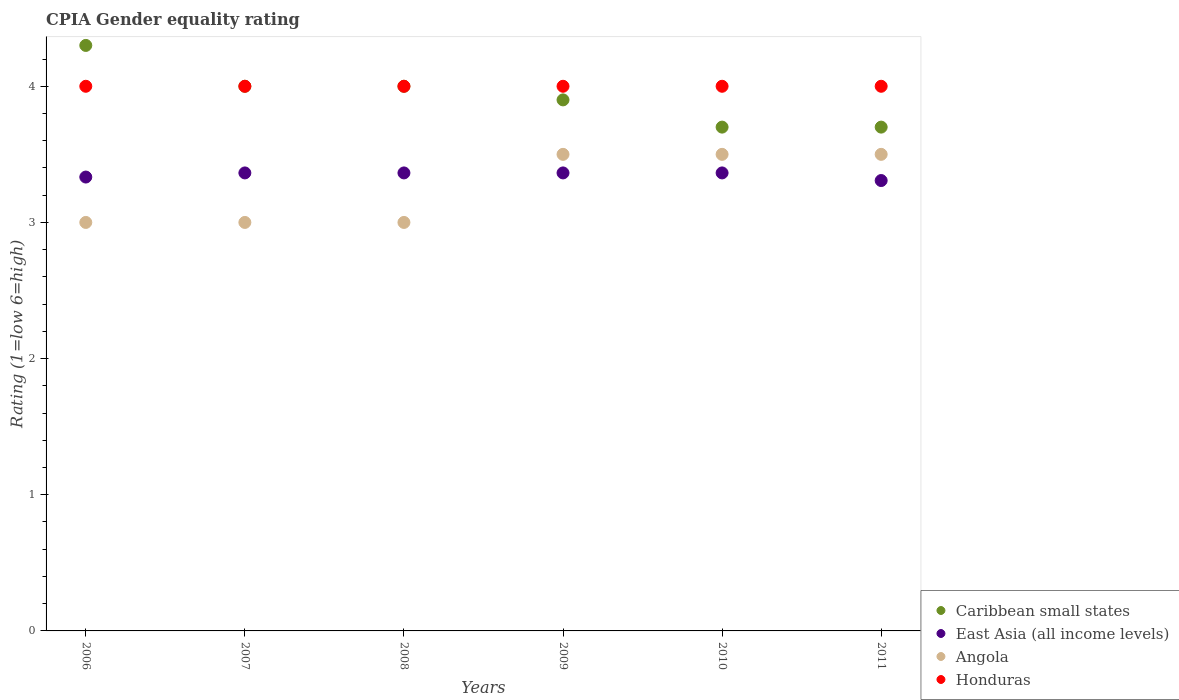How many different coloured dotlines are there?
Keep it short and to the point. 4. Is the number of dotlines equal to the number of legend labels?
Provide a short and direct response. Yes. What is the CPIA rating in East Asia (all income levels) in 2008?
Ensure brevity in your answer.  3.36. Across all years, what is the maximum CPIA rating in Angola?
Your answer should be compact. 3.5. What is the difference between the CPIA rating in Angola in 2006 and that in 2011?
Offer a very short reply. -0.5. What is the difference between the CPIA rating in Honduras in 2006 and the CPIA rating in East Asia (all income levels) in 2011?
Provide a short and direct response. 0.69. What is the average CPIA rating in Caribbean small states per year?
Provide a short and direct response. 3.93. In the year 2010, what is the difference between the CPIA rating in East Asia (all income levels) and CPIA rating in Caribbean small states?
Provide a short and direct response. -0.34. In how many years, is the CPIA rating in Honduras greater than 1.8?
Keep it short and to the point. 6. What is the ratio of the CPIA rating in East Asia (all income levels) in 2006 to that in 2010?
Ensure brevity in your answer.  0.99. Is the CPIA rating in Honduras in 2009 less than that in 2010?
Offer a terse response. No. What is the difference between the highest and the second highest CPIA rating in Caribbean small states?
Ensure brevity in your answer.  0.3. In how many years, is the CPIA rating in Caribbean small states greater than the average CPIA rating in Caribbean small states taken over all years?
Your answer should be compact. 3. Is it the case that in every year, the sum of the CPIA rating in Caribbean small states and CPIA rating in Honduras  is greater than the sum of CPIA rating in East Asia (all income levels) and CPIA rating in Angola?
Provide a short and direct response. No. Is it the case that in every year, the sum of the CPIA rating in Angola and CPIA rating in Honduras  is greater than the CPIA rating in Caribbean small states?
Provide a short and direct response. Yes. Is the CPIA rating in Honduras strictly less than the CPIA rating in East Asia (all income levels) over the years?
Your answer should be very brief. No. What is the difference between two consecutive major ticks on the Y-axis?
Ensure brevity in your answer.  1. Does the graph contain any zero values?
Your answer should be compact. No. Does the graph contain grids?
Provide a short and direct response. No. Where does the legend appear in the graph?
Provide a short and direct response. Bottom right. How many legend labels are there?
Make the answer very short. 4. How are the legend labels stacked?
Make the answer very short. Vertical. What is the title of the graph?
Give a very brief answer. CPIA Gender equality rating. Does "Congo (Republic)" appear as one of the legend labels in the graph?
Ensure brevity in your answer.  No. What is the label or title of the Y-axis?
Make the answer very short. Rating (1=low 6=high). What is the Rating (1=low 6=high) in East Asia (all income levels) in 2006?
Your answer should be very brief. 3.33. What is the Rating (1=low 6=high) in Caribbean small states in 2007?
Keep it short and to the point. 4. What is the Rating (1=low 6=high) in East Asia (all income levels) in 2007?
Provide a short and direct response. 3.36. What is the Rating (1=low 6=high) in Angola in 2007?
Keep it short and to the point. 3. What is the Rating (1=low 6=high) of Honduras in 2007?
Make the answer very short. 4. What is the Rating (1=low 6=high) in East Asia (all income levels) in 2008?
Your answer should be very brief. 3.36. What is the Rating (1=low 6=high) of Honduras in 2008?
Provide a short and direct response. 4. What is the Rating (1=low 6=high) in Caribbean small states in 2009?
Provide a succinct answer. 3.9. What is the Rating (1=low 6=high) of East Asia (all income levels) in 2009?
Ensure brevity in your answer.  3.36. What is the Rating (1=low 6=high) of Angola in 2009?
Give a very brief answer. 3.5. What is the Rating (1=low 6=high) of East Asia (all income levels) in 2010?
Make the answer very short. 3.36. What is the Rating (1=low 6=high) of Caribbean small states in 2011?
Provide a short and direct response. 3.7. What is the Rating (1=low 6=high) in East Asia (all income levels) in 2011?
Your answer should be very brief. 3.31. What is the Rating (1=low 6=high) in Angola in 2011?
Offer a very short reply. 3.5. What is the Rating (1=low 6=high) of Honduras in 2011?
Offer a terse response. 4. Across all years, what is the maximum Rating (1=low 6=high) in Caribbean small states?
Offer a terse response. 4.3. Across all years, what is the maximum Rating (1=low 6=high) of East Asia (all income levels)?
Your answer should be compact. 3.36. Across all years, what is the maximum Rating (1=low 6=high) of Honduras?
Give a very brief answer. 4. Across all years, what is the minimum Rating (1=low 6=high) of East Asia (all income levels)?
Make the answer very short. 3.31. Across all years, what is the minimum Rating (1=low 6=high) of Angola?
Make the answer very short. 3. What is the total Rating (1=low 6=high) in Caribbean small states in the graph?
Make the answer very short. 23.6. What is the total Rating (1=low 6=high) of East Asia (all income levels) in the graph?
Your answer should be very brief. 20.1. What is the total Rating (1=low 6=high) of Honduras in the graph?
Offer a terse response. 24. What is the difference between the Rating (1=low 6=high) in East Asia (all income levels) in 2006 and that in 2007?
Offer a very short reply. -0.03. What is the difference between the Rating (1=low 6=high) in Angola in 2006 and that in 2007?
Your response must be concise. 0. What is the difference between the Rating (1=low 6=high) in Honduras in 2006 and that in 2007?
Your answer should be compact. 0. What is the difference between the Rating (1=low 6=high) of East Asia (all income levels) in 2006 and that in 2008?
Keep it short and to the point. -0.03. What is the difference between the Rating (1=low 6=high) in Honduras in 2006 and that in 2008?
Offer a terse response. 0. What is the difference between the Rating (1=low 6=high) in East Asia (all income levels) in 2006 and that in 2009?
Keep it short and to the point. -0.03. What is the difference between the Rating (1=low 6=high) in Honduras in 2006 and that in 2009?
Your answer should be compact. 0. What is the difference between the Rating (1=low 6=high) of Caribbean small states in 2006 and that in 2010?
Your answer should be very brief. 0.6. What is the difference between the Rating (1=low 6=high) of East Asia (all income levels) in 2006 and that in 2010?
Provide a succinct answer. -0.03. What is the difference between the Rating (1=low 6=high) of Honduras in 2006 and that in 2010?
Your answer should be compact. 0. What is the difference between the Rating (1=low 6=high) of East Asia (all income levels) in 2006 and that in 2011?
Provide a short and direct response. 0.03. What is the difference between the Rating (1=low 6=high) in Caribbean small states in 2007 and that in 2008?
Offer a terse response. 0. What is the difference between the Rating (1=low 6=high) of Angola in 2007 and that in 2008?
Make the answer very short. 0. What is the difference between the Rating (1=low 6=high) in Honduras in 2007 and that in 2008?
Your response must be concise. 0. What is the difference between the Rating (1=low 6=high) of Caribbean small states in 2007 and that in 2009?
Provide a short and direct response. 0.1. What is the difference between the Rating (1=low 6=high) of Caribbean small states in 2007 and that in 2011?
Offer a terse response. 0.3. What is the difference between the Rating (1=low 6=high) of East Asia (all income levels) in 2007 and that in 2011?
Provide a short and direct response. 0.06. What is the difference between the Rating (1=low 6=high) of Angola in 2007 and that in 2011?
Your answer should be very brief. -0.5. What is the difference between the Rating (1=low 6=high) in Honduras in 2008 and that in 2009?
Offer a very short reply. 0. What is the difference between the Rating (1=low 6=high) of Caribbean small states in 2008 and that in 2010?
Ensure brevity in your answer.  0.3. What is the difference between the Rating (1=low 6=high) of Honduras in 2008 and that in 2010?
Make the answer very short. 0. What is the difference between the Rating (1=low 6=high) in East Asia (all income levels) in 2008 and that in 2011?
Ensure brevity in your answer.  0.06. What is the difference between the Rating (1=low 6=high) of East Asia (all income levels) in 2009 and that in 2010?
Your answer should be compact. 0. What is the difference between the Rating (1=low 6=high) of Honduras in 2009 and that in 2010?
Your response must be concise. 0. What is the difference between the Rating (1=low 6=high) of East Asia (all income levels) in 2009 and that in 2011?
Provide a short and direct response. 0.06. What is the difference between the Rating (1=low 6=high) of Caribbean small states in 2010 and that in 2011?
Ensure brevity in your answer.  0. What is the difference between the Rating (1=low 6=high) in East Asia (all income levels) in 2010 and that in 2011?
Provide a succinct answer. 0.06. What is the difference between the Rating (1=low 6=high) of Angola in 2010 and that in 2011?
Give a very brief answer. 0. What is the difference between the Rating (1=low 6=high) of Caribbean small states in 2006 and the Rating (1=low 6=high) of East Asia (all income levels) in 2007?
Provide a succinct answer. 0.94. What is the difference between the Rating (1=low 6=high) in Caribbean small states in 2006 and the Rating (1=low 6=high) in East Asia (all income levels) in 2008?
Make the answer very short. 0.94. What is the difference between the Rating (1=low 6=high) of Caribbean small states in 2006 and the Rating (1=low 6=high) of Honduras in 2008?
Your answer should be very brief. 0.3. What is the difference between the Rating (1=low 6=high) of East Asia (all income levels) in 2006 and the Rating (1=low 6=high) of Honduras in 2008?
Provide a succinct answer. -0.67. What is the difference between the Rating (1=low 6=high) in Caribbean small states in 2006 and the Rating (1=low 6=high) in East Asia (all income levels) in 2009?
Your response must be concise. 0.94. What is the difference between the Rating (1=low 6=high) in Caribbean small states in 2006 and the Rating (1=low 6=high) in Angola in 2009?
Keep it short and to the point. 0.8. What is the difference between the Rating (1=low 6=high) in Caribbean small states in 2006 and the Rating (1=low 6=high) in Honduras in 2009?
Ensure brevity in your answer.  0.3. What is the difference between the Rating (1=low 6=high) of East Asia (all income levels) in 2006 and the Rating (1=low 6=high) of Angola in 2009?
Provide a short and direct response. -0.17. What is the difference between the Rating (1=low 6=high) in Angola in 2006 and the Rating (1=low 6=high) in Honduras in 2009?
Provide a succinct answer. -1. What is the difference between the Rating (1=low 6=high) in Caribbean small states in 2006 and the Rating (1=low 6=high) in East Asia (all income levels) in 2010?
Offer a terse response. 0.94. What is the difference between the Rating (1=low 6=high) in Caribbean small states in 2006 and the Rating (1=low 6=high) in Angola in 2010?
Offer a terse response. 0.8. What is the difference between the Rating (1=low 6=high) in Caribbean small states in 2006 and the Rating (1=low 6=high) in Honduras in 2010?
Your response must be concise. 0.3. What is the difference between the Rating (1=low 6=high) of Angola in 2006 and the Rating (1=low 6=high) of Honduras in 2010?
Provide a short and direct response. -1. What is the difference between the Rating (1=low 6=high) of East Asia (all income levels) in 2006 and the Rating (1=low 6=high) of Angola in 2011?
Keep it short and to the point. -0.17. What is the difference between the Rating (1=low 6=high) of East Asia (all income levels) in 2006 and the Rating (1=low 6=high) of Honduras in 2011?
Your response must be concise. -0.67. What is the difference between the Rating (1=low 6=high) of Angola in 2006 and the Rating (1=low 6=high) of Honduras in 2011?
Provide a succinct answer. -1. What is the difference between the Rating (1=low 6=high) in Caribbean small states in 2007 and the Rating (1=low 6=high) in East Asia (all income levels) in 2008?
Provide a short and direct response. 0.64. What is the difference between the Rating (1=low 6=high) of Caribbean small states in 2007 and the Rating (1=low 6=high) of Honduras in 2008?
Keep it short and to the point. 0. What is the difference between the Rating (1=low 6=high) in East Asia (all income levels) in 2007 and the Rating (1=low 6=high) in Angola in 2008?
Provide a succinct answer. 0.36. What is the difference between the Rating (1=low 6=high) of East Asia (all income levels) in 2007 and the Rating (1=low 6=high) of Honduras in 2008?
Make the answer very short. -0.64. What is the difference between the Rating (1=low 6=high) of Angola in 2007 and the Rating (1=low 6=high) of Honduras in 2008?
Ensure brevity in your answer.  -1. What is the difference between the Rating (1=low 6=high) of Caribbean small states in 2007 and the Rating (1=low 6=high) of East Asia (all income levels) in 2009?
Your answer should be very brief. 0.64. What is the difference between the Rating (1=low 6=high) in Caribbean small states in 2007 and the Rating (1=low 6=high) in Angola in 2009?
Provide a succinct answer. 0.5. What is the difference between the Rating (1=low 6=high) of Caribbean small states in 2007 and the Rating (1=low 6=high) of Honduras in 2009?
Make the answer very short. 0. What is the difference between the Rating (1=low 6=high) in East Asia (all income levels) in 2007 and the Rating (1=low 6=high) in Angola in 2009?
Offer a very short reply. -0.14. What is the difference between the Rating (1=low 6=high) of East Asia (all income levels) in 2007 and the Rating (1=low 6=high) of Honduras in 2009?
Keep it short and to the point. -0.64. What is the difference between the Rating (1=low 6=high) in Angola in 2007 and the Rating (1=low 6=high) in Honduras in 2009?
Provide a short and direct response. -1. What is the difference between the Rating (1=low 6=high) in Caribbean small states in 2007 and the Rating (1=low 6=high) in East Asia (all income levels) in 2010?
Provide a short and direct response. 0.64. What is the difference between the Rating (1=low 6=high) in Caribbean small states in 2007 and the Rating (1=low 6=high) in Angola in 2010?
Provide a succinct answer. 0.5. What is the difference between the Rating (1=low 6=high) in Caribbean small states in 2007 and the Rating (1=low 6=high) in Honduras in 2010?
Give a very brief answer. 0. What is the difference between the Rating (1=low 6=high) of East Asia (all income levels) in 2007 and the Rating (1=low 6=high) of Angola in 2010?
Your answer should be compact. -0.14. What is the difference between the Rating (1=low 6=high) of East Asia (all income levels) in 2007 and the Rating (1=low 6=high) of Honduras in 2010?
Keep it short and to the point. -0.64. What is the difference between the Rating (1=low 6=high) of Caribbean small states in 2007 and the Rating (1=low 6=high) of East Asia (all income levels) in 2011?
Offer a very short reply. 0.69. What is the difference between the Rating (1=low 6=high) in East Asia (all income levels) in 2007 and the Rating (1=low 6=high) in Angola in 2011?
Ensure brevity in your answer.  -0.14. What is the difference between the Rating (1=low 6=high) in East Asia (all income levels) in 2007 and the Rating (1=low 6=high) in Honduras in 2011?
Offer a very short reply. -0.64. What is the difference between the Rating (1=low 6=high) in Caribbean small states in 2008 and the Rating (1=low 6=high) in East Asia (all income levels) in 2009?
Provide a short and direct response. 0.64. What is the difference between the Rating (1=low 6=high) in Caribbean small states in 2008 and the Rating (1=low 6=high) in Angola in 2009?
Keep it short and to the point. 0.5. What is the difference between the Rating (1=low 6=high) in Caribbean small states in 2008 and the Rating (1=low 6=high) in Honduras in 2009?
Make the answer very short. 0. What is the difference between the Rating (1=low 6=high) in East Asia (all income levels) in 2008 and the Rating (1=low 6=high) in Angola in 2009?
Your answer should be very brief. -0.14. What is the difference between the Rating (1=low 6=high) of East Asia (all income levels) in 2008 and the Rating (1=low 6=high) of Honduras in 2009?
Offer a very short reply. -0.64. What is the difference between the Rating (1=low 6=high) of Angola in 2008 and the Rating (1=low 6=high) of Honduras in 2009?
Offer a very short reply. -1. What is the difference between the Rating (1=low 6=high) of Caribbean small states in 2008 and the Rating (1=low 6=high) of East Asia (all income levels) in 2010?
Give a very brief answer. 0.64. What is the difference between the Rating (1=low 6=high) in Caribbean small states in 2008 and the Rating (1=low 6=high) in Honduras in 2010?
Your response must be concise. 0. What is the difference between the Rating (1=low 6=high) of East Asia (all income levels) in 2008 and the Rating (1=low 6=high) of Angola in 2010?
Offer a terse response. -0.14. What is the difference between the Rating (1=low 6=high) in East Asia (all income levels) in 2008 and the Rating (1=low 6=high) in Honduras in 2010?
Your answer should be compact. -0.64. What is the difference between the Rating (1=low 6=high) of Caribbean small states in 2008 and the Rating (1=low 6=high) of East Asia (all income levels) in 2011?
Your response must be concise. 0.69. What is the difference between the Rating (1=low 6=high) in Caribbean small states in 2008 and the Rating (1=low 6=high) in Honduras in 2011?
Your answer should be very brief. 0. What is the difference between the Rating (1=low 6=high) in East Asia (all income levels) in 2008 and the Rating (1=low 6=high) in Angola in 2011?
Provide a short and direct response. -0.14. What is the difference between the Rating (1=low 6=high) of East Asia (all income levels) in 2008 and the Rating (1=low 6=high) of Honduras in 2011?
Your answer should be very brief. -0.64. What is the difference between the Rating (1=low 6=high) of Caribbean small states in 2009 and the Rating (1=low 6=high) of East Asia (all income levels) in 2010?
Offer a very short reply. 0.54. What is the difference between the Rating (1=low 6=high) of Caribbean small states in 2009 and the Rating (1=low 6=high) of Angola in 2010?
Give a very brief answer. 0.4. What is the difference between the Rating (1=low 6=high) of East Asia (all income levels) in 2009 and the Rating (1=low 6=high) of Angola in 2010?
Provide a short and direct response. -0.14. What is the difference between the Rating (1=low 6=high) of East Asia (all income levels) in 2009 and the Rating (1=low 6=high) of Honduras in 2010?
Make the answer very short. -0.64. What is the difference between the Rating (1=low 6=high) in Angola in 2009 and the Rating (1=low 6=high) in Honduras in 2010?
Offer a very short reply. -0.5. What is the difference between the Rating (1=low 6=high) in Caribbean small states in 2009 and the Rating (1=low 6=high) in East Asia (all income levels) in 2011?
Keep it short and to the point. 0.59. What is the difference between the Rating (1=low 6=high) in Caribbean small states in 2009 and the Rating (1=low 6=high) in Honduras in 2011?
Offer a terse response. -0.1. What is the difference between the Rating (1=low 6=high) of East Asia (all income levels) in 2009 and the Rating (1=low 6=high) of Angola in 2011?
Give a very brief answer. -0.14. What is the difference between the Rating (1=low 6=high) in East Asia (all income levels) in 2009 and the Rating (1=low 6=high) in Honduras in 2011?
Give a very brief answer. -0.64. What is the difference between the Rating (1=low 6=high) of Caribbean small states in 2010 and the Rating (1=low 6=high) of East Asia (all income levels) in 2011?
Make the answer very short. 0.39. What is the difference between the Rating (1=low 6=high) in Caribbean small states in 2010 and the Rating (1=low 6=high) in Angola in 2011?
Offer a very short reply. 0.2. What is the difference between the Rating (1=low 6=high) in East Asia (all income levels) in 2010 and the Rating (1=low 6=high) in Angola in 2011?
Offer a very short reply. -0.14. What is the difference between the Rating (1=low 6=high) of East Asia (all income levels) in 2010 and the Rating (1=low 6=high) of Honduras in 2011?
Offer a very short reply. -0.64. What is the average Rating (1=low 6=high) of Caribbean small states per year?
Your response must be concise. 3.93. What is the average Rating (1=low 6=high) in East Asia (all income levels) per year?
Ensure brevity in your answer.  3.35. What is the average Rating (1=low 6=high) of Angola per year?
Give a very brief answer. 3.25. What is the average Rating (1=low 6=high) in Honduras per year?
Your answer should be very brief. 4. In the year 2006, what is the difference between the Rating (1=low 6=high) in Caribbean small states and Rating (1=low 6=high) in East Asia (all income levels)?
Your answer should be compact. 0.97. In the year 2006, what is the difference between the Rating (1=low 6=high) of Caribbean small states and Rating (1=low 6=high) of Honduras?
Your response must be concise. 0.3. In the year 2006, what is the difference between the Rating (1=low 6=high) of East Asia (all income levels) and Rating (1=low 6=high) of Honduras?
Your answer should be very brief. -0.67. In the year 2006, what is the difference between the Rating (1=low 6=high) of Angola and Rating (1=low 6=high) of Honduras?
Your answer should be compact. -1. In the year 2007, what is the difference between the Rating (1=low 6=high) of Caribbean small states and Rating (1=low 6=high) of East Asia (all income levels)?
Offer a very short reply. 0.64. In the year 2007, what is the difference between the Rating (1=low 6=high) in Caribbean small states and Rating (1=low 6=high) in Angola?
Keep it short and to the point. 1. In the year 2007, what is the difference between the Rating (1=low 6=high) in Caribbean small states and Rating (1=low 6=high) in Honduras?
Provide a succinct answer. 0. In the year 2007, what is the difference between the Rating (1=low 6=high) of East Asia (all income levels) and Rating (1=low 6=high) of Angola?
Offer a terse response. 0.36. In the year 2007, what is the difference between the Rating (1=low 6=high) of East Asia (all income levels) and Rating (1=low 6=high) of Honduras?
Offer a very short reply. -0.64. In the year 2007, what is the difference between the Rating (1=low 6=high) in Angola and Rating (1=low 6=high) in Honduras?
Your answer should be compact. -1. In the year 2008, what is the difference between the Rating (1=low 6=high) in Caribbean small states and Rating (1=low 6=high) in East Asia (all income levels)?
Provide a succinct answer. 0.64. In the year 2008, what is the difference between the Rating (1=low 6=high) of East Asia (all income levels) and Rating (1=low 6=high) of Angola?
Keep it short and to the point. 0.36. In the year 2008, what is the difference between the Rating (1=low 6=high) of East Asia (all income levels) and Rating (1=low 6=high) of Honduras?
Offer a terse response. -0.64. In the year 2009, what is the difference between the Rating (1=low 6=high) of Caribbean small states and Rating (1=low 6=high) of East Asia (all income levels)?
Keep it short and to the point. 0.54. In the year 2009, what is the difference between the Rating (1=low 6=high) of Caribbean small states and Rating (1=low 6=high) of Angola?
Provide a short and direct response. 0.4. In the year 2009, what is the difference between the Rating (1=low 6=high) in Caribbean small states and Rating (1=low 6=high) in Honduras?
Your response must be concise. -0.1. In the year 2009, what is the difference between the Rating (1=low 6=high) in East Asia (all income levels) and Rating (1=low 6=high) in Angola?
Your answer should be very brief. -0.14. In the year 2009, what is the difference between the Rating (1=low 6=high) in East Asia (all income levels) and Rating (1=low 6=high) in Honduras?
Provide a succinct answer. -0.64. In the year 2010, what is the difference between the Rating (1=low 6=high) of Caribbean small states and Rating (1=low 6=high) of East Asia (all income levels)?
Provide a succinct answer. 0.34. In the year 2010, what is the difference between the Rating (1=low 6=high) in East Asia (all income levels) and Rating (1=low 6=high) in Angola?
Your response must be concise. -0.14. In the year 2010, what is the difference between the Rating (1=low 6=high) in East Asia (all income levels) and Rating (1=low 6=high) in Honduras?
Give a very brief answer. -0.64. In the year 2010, what is the difference between the Rating (1=low 6=high) of Angola and Rating (1=low 6=high) of Honduras?
Offer a very short reply. -0.5. In the year 2011, what is the difference between the Rating (1=low 6=high) in Caribbean small states and Rating (1=low 6=high) in East Asia (all income levels)?
Provide a succinct answer. 0.39. In the year 2011, what is the difference between the Rating (1=low 6=high) in East Asia (all income levels) and Rating (1=low 6=high) in Angola?
Your answer should be compact. -0.19. In the year 2011, what is the difference between the Rating (1=low 6=high) in East Asia (all income levels) and Rating (1=low 6=high) in Honduras?
Your response must be concise. -0.69. In the year 2011, what is the difference between the Rating (1=low 6=high) of Angola and Rating (1=low 6=high) of Honduras?
Your answer should be compact. -0.5. What is the ratio of the Rating (1=low 6=high) of Caribbean small states in 2006 to that in 2007?
Your response must be concise. 1.07. What is the ratio of the Rating (1=low 6=high) in Angola in 2006 to that in 2007?
Provide a short and direct response. 1. What is the ratio of the Rating (1=low 6=high) in Caribbean small states in 2006 to that in 2008?
Ensure brevity in your answer.  1.07. What is the ratio of the Rating (1=low 6=high) in East Asia (all income levels) in 2006 to that in 2008?
Offer a terse response. 0.99. What is the ratio of the Rating (1=low 6=high) in Caribbean small states in 2006 to that in 2009?
Your response must be concise. 1.1. What is the ratio of the Rating (1=low 6=high) of East Asia (all income levels) in 2006 to that in 2009?
Offer a very short reply. 0.99. What is the ratio of the Rating (1=low 6=high) in Caribbean small states in 2006 to that in 2010?
Make the answer very short. 1.16. What is the ratio of the Rating (1=low 6=high) in East Asia (all income levels) in 2006 to that in 2010?
Offer a very short reply. 0.99. What is the ratio of the Rating (1=low 6=high) of Caribbean small states in 2006 to that in 2011?
Make the answer very short. 1.16. What is the ratio of the Rating (1=low 6=high) of Caribbean small states in 2007 to that in 2008?
Provide a succinct answer. 1. What is the ratio of the Rating (1=low 6=high) in Honduras in 2007 to that in 2008?
Offer a terse response. 1. What is the ratio of the Rating (1=low 6=high) of Caribbean small states in 2007 to that in 2009?
Your response must be concise. 1.03. What is the ratio of the Rating (1=low 6=high) of East Asia (all income levels) in 2007 to that in 2009?
Keep it short and to the point. 1. What is the ratio of the Rating (1=low 6=high) in Angola in 2007 to that in 2009?
Provide a short and direct response. 0.86. What is the ratio of the Rating (1=low 6=high) in Caribbean small states in 2007 to that in 2010?
Your answer should be very brief. 1.08. What is the ratio of the Rating (1=low 6=high) of Caribbean small states in 2007 to that in 2011?
Offer a very short reply. 1.08. What is the ratio of the Rating (1=low 6=high) of East Asia (all income levels) in 2007 to that in 2011?
Provide a short and direct response. 1.02. What is the ratio of the Rating (1=low 6=high) in Honduras in 2007 to that in 2011?
Make the answer very short. 1. What is the ratio of the Rating (1=low 6=high) of Caribbean small states in 2008 to that in 2009?
Ensure brevity in your answer.  1.03. What is the ratio of the Rating (1=low 6=high) of Caribbean small states in 2008 to that in 2010?
Make the answer very short. 1.08. What is the ratio of the Rating (1=low 6=high) of Caribbean small states in 2008 to that in 2011?
Your answer should be very brief. 1.08. What is the ratio of the Rating (1=low 6=high) of East Asia (all income levels) in 2008 to that in 2011?
Your answer should be very brief. 1.02. What is the ratio of the Rating (1=low 6=high) of Caribbean small states in 2009 to that in 2010?
Provide a succinct answer. 1.05. What is the ratio of the Rating (1=low 6=high) in East Asia (all income levels) in 2009 to that in 2010?
Your answer should be compact. 1. What is the ratio of the Rating (1=low 6=high) of Honduras in 2009 to that in 2010?
Provide a short and direct response. 1. What is the ratio of the Rating (1=low 6=high) in Caribbean small states in 2009 to that in 2011?
Offer a terse response. 1.05. What is the ratio of the Rating (1=low 6=high) in East Asia (all income levels) in 2009 to that in 2011?
Your answer should be very brief. 1.02. What is the ratio of the Rating (1=low 6=high) in Angola in 2009 to that in 2011?
Provide a succinct answer. 1. What is the ratio of the Rating (1=low 6=high) of Honduras in 2009 to that in 2011?
Keep it short and to the point. 1. What is the ratio of the Rating (1=low 6=high) of East Asia (all income levels) in 2010 to that in 2011?
Provide a short and direct response. 1.02. What is the ratio of the Rating (1=low 6=high) in Angola in 2010 to that in 2011?
Ensure brevity in your answer.  1. What is the difference between the highest and the second highest Rating (1=low 6=high) in East Asia (all income levels)?
Provide a succinct answer. 0. What is the difference between the highest and the second highest Rating (1=low 6=high) of Honduras?
Provide a short and direct response. 0. What is the difference between the highest and the lowest Rating (1=low 6=high) of Caribbean small states?
Provide a succinct answer. 0.6. What is the difference between the highest and the lowest Rating (1=low 6=high) of East Asia (all income levels)?
Your answer should be compact. 0.06. What is the difference between the highest and the lowest Rating (1=low 6=high) in Angola?
Offer a very short reply. 0.5. What is the difference between the highest and the lowest Rating (1=low 6=high) of Honduras?
Provide a short and direct response. 0. 